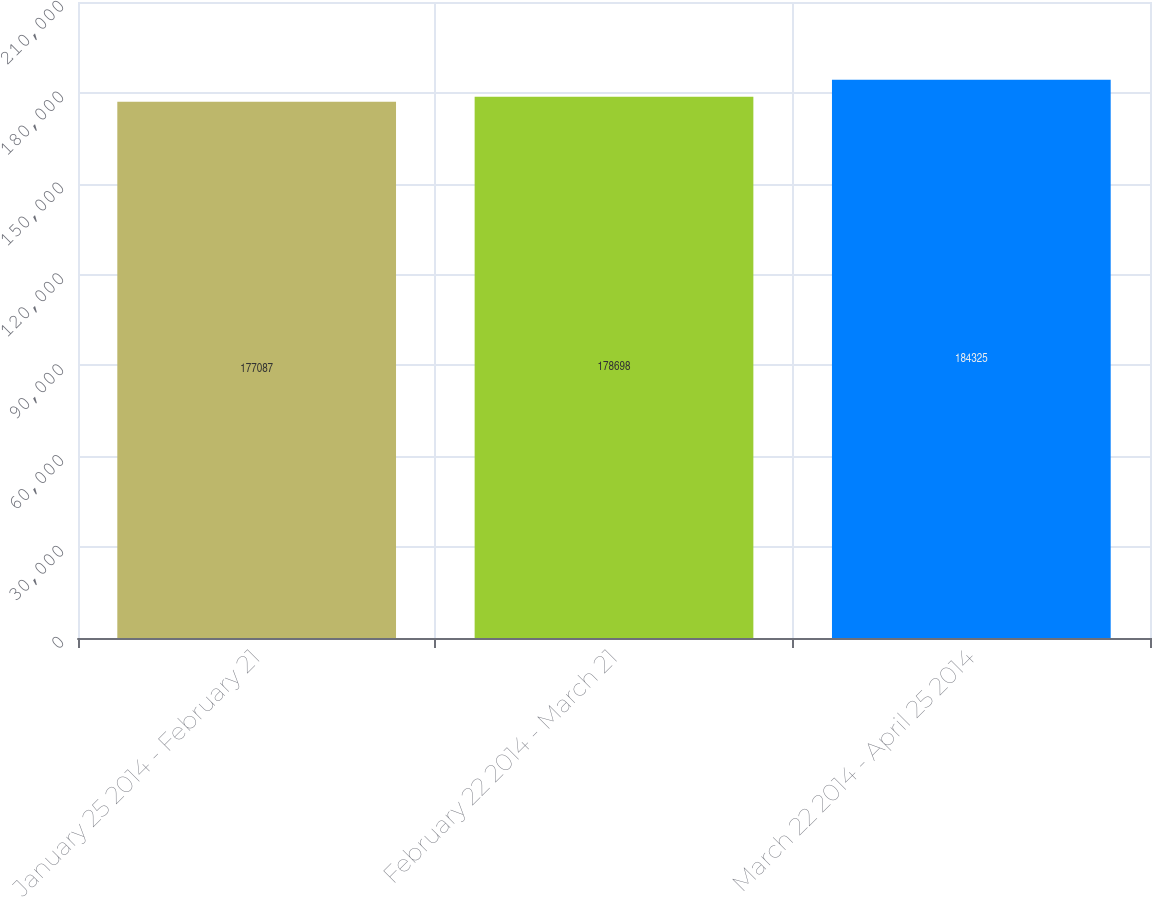<chart> <loc_0><loc_0><loc_500><loc_500><bar_chart><fcel>January 25 2014 - February 21<fcel>February 22 2014 - March 21<fcel>March 22 2014 - April 25 2014<nl><fcel>177087<fcel>178698<fcel>184325<nl></chart> 